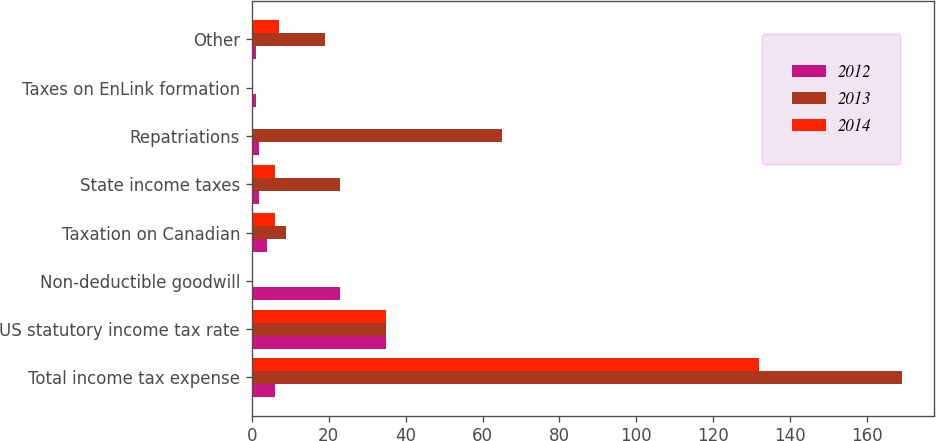<chart> <loc_0><loc_0><loc_500><loc_500><stacked_bar_chart><ecel><fcel>Total income tax expense<fcel>US statutory income tax rate<fcel>Non-deductible goodwill<fcel>Taxation on Canadian<fcel>State income taxes<fcel>Repatriations<fcel>Taxes on EnLink formation<fcel>Other<nl><fcel>2012<fcel>6<fcel>35<fcel>23<fcel>4<fcel>2<fcel>2<fcel>1<fcel>1<nl><fcel>2013<fcel>169<fcel>35<fcel>0<fcel>9<fcel>23<fcel>65<fcel>0<fcel>19<nl><fcel>2014<fcel>132<fcel>35<fcel>0<fcel>6<fcel>6<fcel>0<fcel>0<fcel>7<nl></chart> 